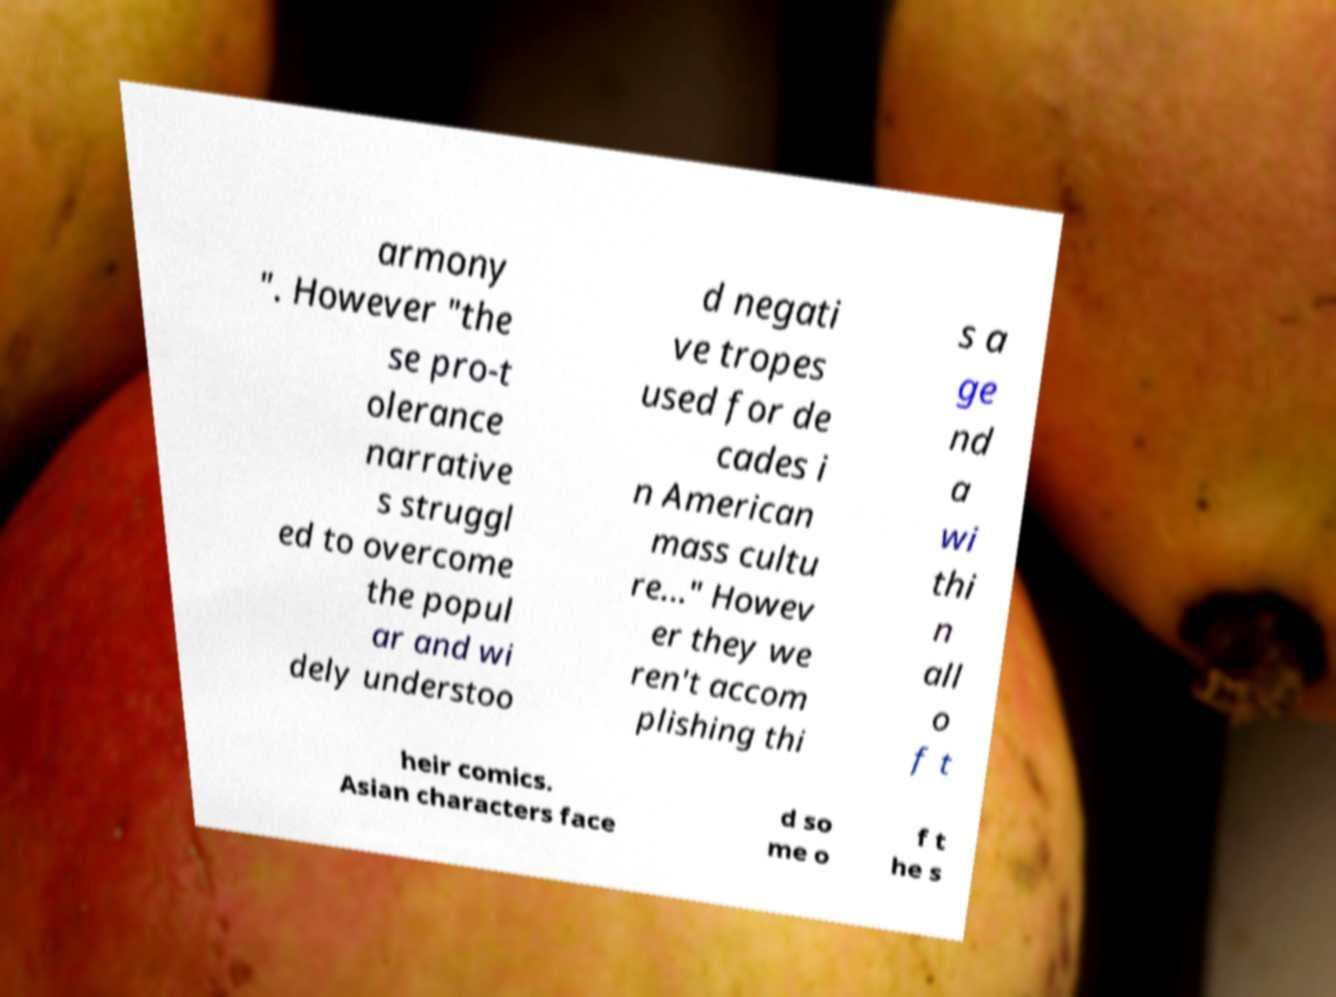Please read and relay the text visible in this image. What does it say? armony ". However "the se pro-t olerance narrative s struggl ed to overcome the popul ar and wi dely understoo d negati ve tropes used for de cades i n American mass cultu re..." Howev er they we ren't accom plishing thi s a ge nd a wi thi n all o f t heir comics. Asian characters face d so me o f t he s 